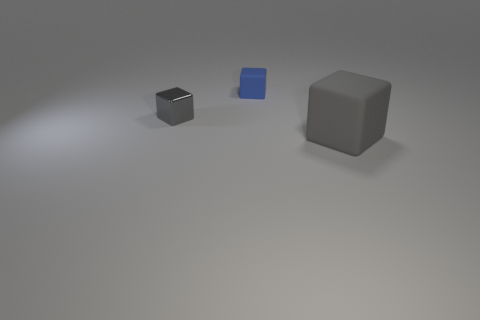Add 1 small blue balls. How many objects exist? 4 Subtract 0 purple spheres. How many objects are left? 3 Subtract all blue rubber cylinders. Subtract all gray matte blocks. How many objects are left? 2 Add 3 small blue things. How many small blue things are left? 4 Add 3 small shiny objects. How many small shiny objects exist? 4 